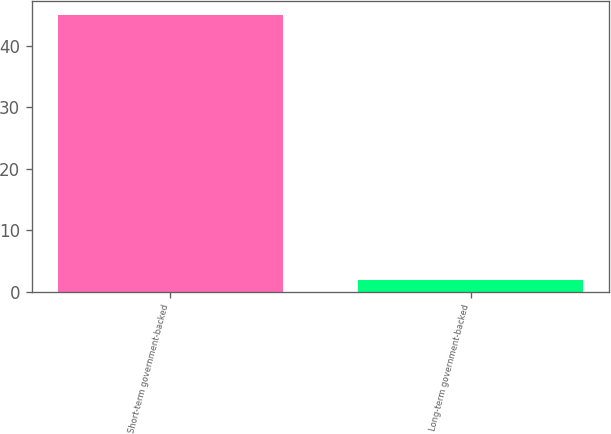<chart> <loc_0><loc_0><loc_500><loc_500><bar_chart><fcel>Short-term government-backed<fcel>Long-term government-backed<nl><fcel>45<fcel>2<nl></chart> 